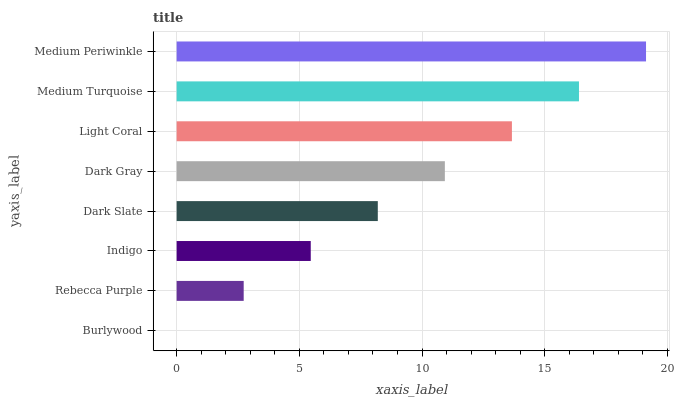Is Burlywood the minimum?
Answer yes or no. Yes. Is Medium Periwinkle the maximum?
Answer yes or no. Yes. Is Rebecca Purple the minimum?
Answer yes or no. No. Is Rebecca Purple the maximum?
Answer yes or no. No. Is Rebecca Purple greater than Burlywood?
Answer yes or no. Yes. Is Burlywood less than Rebecca Purple?
Answer yes or no. Yes. Is Burlywood greater than Rebecca Purple?
Answer yes or no. No. Is Rebecca Purple less than Burlywood?
Answer yes or no. No. Is Dark Gray the high median?
Answer yes or no. Yes. Is Dark Slate the low median?
Answer yes or no. Yes. Is Indigo the high median?
Answer yes or no. No. Is Indigo the low median?
Answer yes or no. No. 